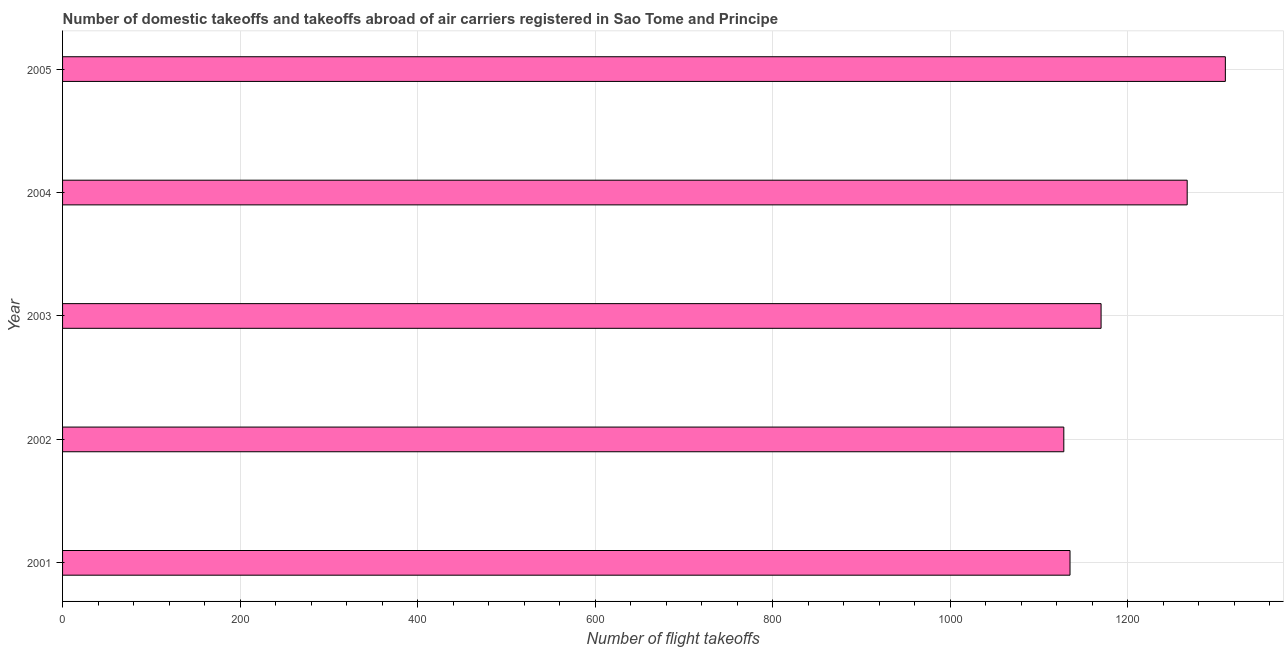What is the title of the graph?
Ensure brevity in your answer.  Number of domestic takeoffs and takeoffs abroad of air carriers registered in Sao Tome and Principe. What is the label or title of the X-axis?
Provide a short and direct response. Number of flight takeoffs. What is the number of flight takeoffs in 2002?
Offer a terse response. 1128. Across all years, what is the maximum number of flight takeoffs?
Provide a short and direct response. 1310. Across all years, what is the minimum number of flight takeoffs?
Provide a short and direct response. 1128. What is the sum of the number of flight takeoffs?
Give a very brief answer. 6010. What is the difference between the number of flight takeoffs in 2002 and 2005?
Offer a very short reply. -182. What is the average number of flight takeoffs per year?
Offer a terse response. 1202. What is the median number of flight takeoffs?
Offer a very short reply. 1170. In how many years, is the number of flight takeoffs greater than 280 ?
Ensure brevity in your answer.  5. What is the ratio of the number of flight takeoffs in 2001 to that in 2004?
Provide a succinct answer. 0.9. Is the number of flight takeoffs in 2001 less than that in 2002?
Provide a short and direct response. No. What is the difference between the highest and the second highest number of flight takeoffs?
Your response must be concise. 43. Is the sum of the number of flight takeoffs in 2003 and 2004 greater than the maximum number of flight takeoffs across all years?
Offer a very short reply. Yes. What is the difference between the highest and the lowest number of flight takeoffs?
Your response must be concise. 182. How many bars are there?
Provide a succinct answer. 5. Are all the bars in the graph horizontal?
Give a very brief answer. Yes. Are the values on the major ticks of X-axis written in scientific E-notation?
Your answer should be compact. No. What is the Number of flight takeoffs of 2001?
Provide a succinct answer. 1135. What is the Number of flight takeoffs of 2002?
Provide a short and direct response. 1128. What is the Number of flight takeoffs of 2003?
Your answer should be compact. 1170. What is the Number of flight takeoffs in 2004?
Your response must be concise. 1267. What is the Number of flight takeoffs in 2005?
Make the answer very short. 1310. What is the difference between the Number of flight takeoffs in 2001 and 2003?
Offer a very short reply. -35. What is the difference between the Number of flight takeoffs in 2001 and 2004?
Your answer should be very brief. -132. What is the difference between the Number of flight takeoffs in 2001 and 2005?
Your answer should be compact. -175. What is the difference between the Number of flight takeoffs in 2002 and 2003?
Provide a succinct answer. -42. What is the difference between the Number of flight takeoffs in 2002 and 2004?
Provide a short and direct response. -139. What is the difference between the Number of flight takeoffs in 2002 and 2005?
Ensure brevity in your answer.  -182. What is the difference between the Number of flight takeoffs in 2003 and 2004?
Offer a very short reply. -97. What is the difference between the Number of flight takeoffs in 2003 and 2005?
Provide a succinct answer. -140. What is the difference between the Number of flight takeoffs in 2004 and 2005?
Make the answer very short. -43. What is the ratio of the Number of flight takeoffs in 2001 to that in 2004?
Make the answer very short. 0.9. What is the ratio of the Number of flight takeoffs in 2001 to that in 2005?
Offer a very short reply. 0.87. What is the ratio of the Number of flight takeoffs in 2002 to that in 2003?
Give a very brief answer. 0.96. What is the ratio of the Number of flight takeoffs in 2002 to that in 2004?
Keep it short and to the point. 0.89. What is the ratio of the Number of flight takeoffs in 2002 to that in 2005?
Provide a succinct answer. 0.86. What is the ratio of the Number of flight takeoffs in 2003 to that in 2004?
Give a very brief answer. 0.92. What is the ratio of the Number of flight takeoffs in 2003 to that in 2005?
Offer a terse response. 0.89. 